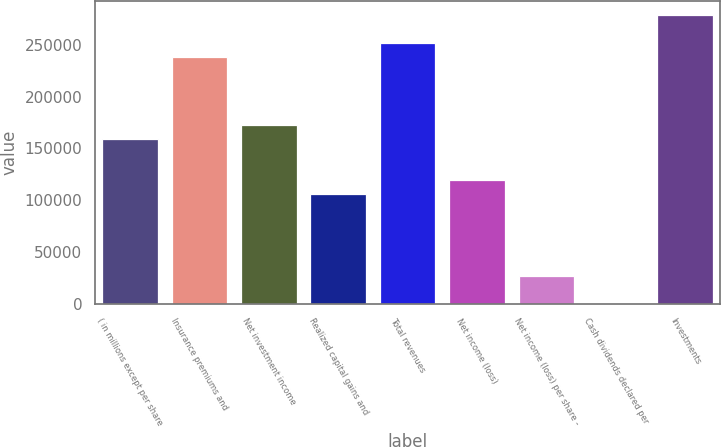Convert chart to OTSL. <chart><loc_0><loc_0><loc_500><loc_500><bar_chart><fcel>( in millions except per share<fcel>Insurance premiums and<fcel>Net investment income<fcel>Realized capital gains and<fcel>Total revenues<fcel>Net income (loss)<fcel>Net income (loss) per share -<fcel>Cash dividends declared per<fcel>Investments<nl><fcel>159182<fcel>238773<fcel>172447<fcel>106122<fcel>252038<fcel>119387<fcel>26531<fcel>0.8<fcel>278568<nl></chart> 